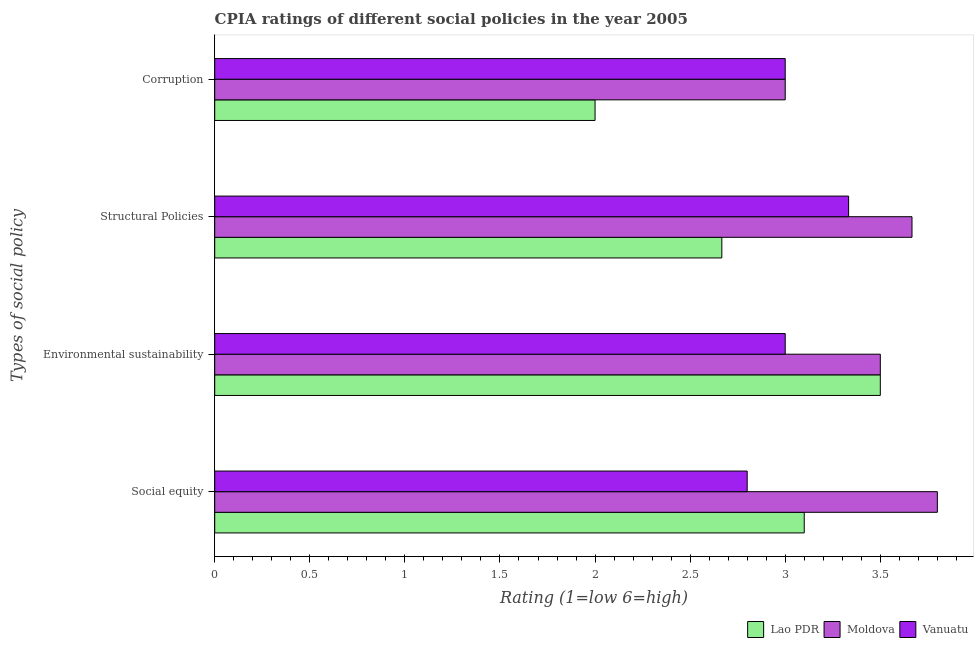How many different coloured bars are there?
Your response must be concise. 3. How many groups of bars are there?
Keep it short and to the point. 4. Are the number of bars per tick equal to the number of legend labels?
Ensure brevity in your answer.  Yes. What is the label of the 3rd group of bars from the top?
Your response must be concise. Environmental sustainability. What is the cpia rating of corruption in Vanuatu?
Offer a terse response. 3. Across all countries, what is the minimum cpia rating of structural policies?
Make the answer very short. 2.67. In which country was the cpia rating of environmental sustainability maximum?
Ensure brevity in your answer.  Lao PDR. In which country was the cpia rating of environmental sustainability minimum?
Ensure brevity in your answer.  Vanuatu. What is the total cpia rating of structural policies in the graph?
Your answer should be compact. 9.67. What is the difference between the cpia rating of structural policies in Vanuatu and that in Lao PDR?
Your answer should be compact. 0.67. What is the difference between the cpia rating of social equity in Vanuatu and the cpia rating of environmental sustainability in Moldova?
Offer a very short reply. -0.7. What is the average cpia rating of corruption per country?
Make the answer very short. 2.67. What is the difference between the cpia rating of environmental sustainability and cpia rating of corruption in Vanuatu?
Ensure brevity in your answer.  0. In how many countries, is the cpia rating of social equity greater than 1.3 ?
Keep it short and to the point. 3. What is the ratio of the cpia rating of structural policies in Moldova to that in Lao PDR?
Offer a terse response. 1.37. Is the difference between the cpia rating of corruption in Moldova and Lao PDR greater than the difference between the cpia rating of social equity in Moldova and Lao PDR?
Your answer should be very brief. Yes. What is the difference between the highest and the second highest cpia rating of social equity?
Ensure brevity in your answer.  0.7. What is the difference between the highest and the lowest cpia rating of social equity?
Your answer should be compact. 1. Is the sum of the cpia rating of social equity in Vanuatu and Lao PDR greater than the maximum cpia rating of environmental sustainability across all countries?
Provide a succinct answer. Yes. What does the 2nd bar from the top in Social equity represents?
Make the answer very short. Moldova. What does the 3rd bar from the bottom in Corruption represents?
Offer a terse response. Vanuatu. Is it the case that in every country, the sum of the cpia rating of social equity and cpia rating of environmental sustainability is greater than the cpia rating of structural policies?
Your answer should be very brief. Yes. How many bars are there?
Offer a very short reply. 12. How many countries are there in the graph?
Offer a terse response. 3. What is the difference between two consecutive major ticks on the X-axis?
Offer a terse response. 0.5. Does the graph contain grids?
Offer a terse response. No. How many legend labels are there?
Keep it short and to the point. 3. How are the legend labels stacked?
Offer a terse response. Horizontal. What is the title of the graph?
Make the answer very short. CPIA ratings of different social policies in the year 2005. What is the label or title of the X-axis?
Your response must be concise. Rating (1=low 6=high). What is the label or title of the Y-axis?
Give a very brief answer. Types of social policy. What is the Rating (1=low 6=high) in Moldova in Environmental sustainability?
Keep it short and to the point. 3.5. What is the Rating (1=low 6=high) of Lao PDR in Structural Policies?
Keep it short and to the point. 2.67. What is the Rating (1=low 6=high) of Moldova in Structural Policies?
Provide a short and direct response. 3.67. What is the Rating (1=low 6=high) of Vanuatu in Structural Policies?
Give a very brief answer. 3.33. What is the Rating (1=low 6=high) in Moldova in Corruption?
Offer a terse response. 3. What is the Rating (1=low 6=high) of Vanuatu in Corruption?
Make the answer very short. 3. Across all Types of social policy, what is the maximum Rating (1=low 6=high) of Moldova?
Keep it short and to the point. 3.8. Across all Types of social policy, what is the maximum Rating (1=low 6=high) of Vanuatu?
Your answer should be compact. 3.33. Across all Types of social policy, what is the minimum Rating (1=low 6=high) of Vanuatu?
Keep it short and to the point. 2.8. What is the total Rating (1=low 6=high) of Lao PDR in the graph?
Offer a terse response. 11.27. What is the total Rating (1=low 6=high) in Moldova in the graph?
Your response must be concise. 13.97. What is the total Rating (1=low 6=high) in Vanuatu in the graph?
Ensure brevity in your answer.  12.13. What is the difference between the Rating (1=low 6=high) of Vanuatu in Social equity and that in Environmental sustainability?
Your response must be concise. -0.2. What is the difference between the Rating (1=low 6=high) of Lao PDR in Social equity and that in Structural Policies?
Give a very brief answer. 0.43. What is the difference between the Rating (1=low 6=high) in Moldova in Social equity and that in Structural Policies?
Provide a short and direct response. 0.13. What is the difference between the Rating (1=low 6=high) in Vanuatu in Social equity and that in Structural Policies?
Your response must be concise. -0.53. What is the difference between the Rating (1=low 6=high) in Moldova in Social equity and that in Corruption?
Offer a very short reply. 0.8. What is the difference between the Rating (1=low 6=high) in Vanuatu in Social equity and that in Corruption?
Offer a terse response. -0.2. What is the difference between the Rating (1=low 6=high) in Lao PDR in Environmental sustainability and that in Structural Policies?
Keep it short and to the point. 0.83. What is the difference between the Rating (1=low 6=high) of Moldova in Environmental sustainability and that in Structural Policies?
Offer a very short reply. -0.17. What is the difference between the Rating (1=low 6=high) of Vanuatu in Environmental sustainability and that in Structural Policies?
Your answer should be very brief. -0.33. What is the difference between the Rating (1=low 6=high) in Moldova in Environmental sustainability and that in Corruption?
Your response must be concise. 0.5. What is the difference between the Rating (1=low 6=high) in Vanuatu in Environmental sustainability and that in Corruption?
Give a very brief answer. 0. What is the difference between the Rating (1=low 6=high) in Lao PDR in Structural Policies and that in Corruption?
Provide a short and direct response. 0.67. What is the difference between the Rating (1=low 6=high) of Moldova in Social equity and the Rating (1=low 6=high) of Vanuatu in Environmental sustainability?
Keep it short and to the point. 0.8. What is the difference between the Rating (1=low 6=high) of Lao PDR in Social equity and the Rating (1=low 6=high) of Moldova in Structural Policies?
Make the answer very short. -0.57. What is the difference between the Rating (1=low 6=high) in Lao PDR in Social equity and the Rating (1=low 6=high) in Vanuatu in Structural Policies?
Offer a terse response. -0.23. What is the difference between the Rating (1=low 6=high) in Moldova in Social equity and the Rating (1=low 6=high) in Vanuatu in Structural Policies?
Offer a terse response. 0.47. What is the difference between the Rating (1=low 6=high) in Lao PDR in Environmental sustainability and the Rating (1=low 6=high) in Vanuatu in Structural Policies?
Provide a succinct answer. 0.17. What is the difference between the Rating (1=low 6=high) of Moldova in Environmental sustainability and the Rating (1=low 6=high) of Vanuatu in Structural Policies?
Offer a very short reply. 0.17. What is the difference between the Rating (1=low 6=high) in Lao PDR in Environmental sustainability and the Rating (1=low 6=high) in Moldova in Corruption?
Make the answer very short. 0.5. What is the difference between the Rating (1=low 6=high) in Lao PDR in Structural Policies and the Rating (1=low 6=high) in Vanuatu in Corruption?
Ensure brevity in your answer.  -0.33. What is the difference between the Rating (1=low 6=high) of Moldova in Structural Policies and the Rating (1=low 6=high) of Vanuatu in Corruption?
Your answer should be very brief. 0.67. What is the average Rating (1=low 6=high) in Lao PDR per Types of social policy?
Make the answer very short. 2.82. What is the average Rating (1=low 6=high) in Moldova per Types of social policy?
Ensure brevity in your answer.  3.49. What is the average Rating (1=low 6=high) of Vanuatu per Types of social policy?
Give a very brief answer. 3.03. What is the difference between the Rating (1=low 6=high) in Lao PDR and Rating (1=low 6=high) in Moldova in Social equity?
Provide a succinct answer. -0.7. What is the difference between the Rating (1=low 6=high) of Lao PDR and Rating (1=low 6=high) of Vanuatu in Social equity?
Offer a very short reply. 0.3. What is the difference between the Rating (1=low 6=high) in Lao PDR and Rating (1=low 6=high) in Moldova in Environmental sustainability?
Provide a short and direct response. 0. What is the difference between the Rating (1=low 6=high) of Lao PDR and Rating (1=low 6=high) of Vanuatu in Environmental sustainability?
Your response must be concise. 0.5. What is the difference between the Rating (1=low 6=high) of Lao PDR and Rating (1=low 6=high) of Moldova in Structural Policies?
Your answer should be compact. -1. What is the difference between the Rating (1=low 6=high) in Lao PDR and Rating (1=low 6=high) in Vanuatu in Structural Policies?
Keep it short and to the point. -0.67. What is the difference between the Rating (1=low 6=high) of Moldova and Rating (1=low 6=high) of Vanuatu in Structural Policies?
Provide a succinct answer. 0.33. What is the difference between the Rating (1=low 6=high) in Lao PDR and Rating (1=low 6=high) in Moldova in Corruption?
Offer a terse response. -1. What is the difference between the Rating (1=low 6=high) of Lao PDR and Rating (1=low 6=high) of Vanuatu in Corruption?
Your answer should be very brief. -1. What is the ratio of the Rating (1=low 6=high) of Lao PDR in Social equity to that in Environmental sustainability?
Provide a succinct answer. 0.89. What is the ratio of the Rating (1=low 6=high) in Moldova in Social equity to that in Environmental sustainability?
Your answer should be very brief. 1.09. What is the ratio of the Rating (1=low 6=high) in Lao PDR in Social equity to that in Structural Policies?
Offer a terse response. 1.16. What is the ratio of the Rating (1=low 6=high) in Moldova in Social equity to that in Structural Policies?
Provide a succinct answer. 1.04. What is the ratio of the Rating (1=low 6=high) of Vanuatu in Social equity to that in Structural Policies?
Provide a succinct answer. 0.84. What is the ratio of the Rating (1=low 6=high) in Lao PDR in Social equity to that in Corruption?
Provide a succinct answer. 1.55. What is the ratio of the Rating (1=low 6=high) in Moldova in Social equity to that in Corruption?
Your answer should be very brief. 1.27. What is the ratio of the Rating (1=low 6=high) in Vanuatu in Social equity to that in Corruption?
Provide a succinct answer. 0.93. What is the ratio of the Rating (1=low 6=high) in Lao PDR in Environmental sustainability to that in Structural Policies?
Provide a succinct answer. 1.31. What is the ratio of the Rating (1=low 6=high) of Moldova in Environmental sustainability to that in Structural Policies?
Your answer should be compact. 0.95. What is the ratio of the Rating (1=low 6=high) in Moldova in Environmental sustainability to that in Corruption?
Offer a very short reply. 1.17. What is the ratio of the Rating (1=low 6=high) of Vanuatu in Environmental sustainability to that in Corruption?
Give a very brief answer. 1. What is the ratio of the Rating (1=low 6=high) in Moldova in Structural Policies to that in Corruption?
Give a very brief answer. 1.22. What is the difference between the highest and the second highest Rating (1=low 6=high) of Moldova?
Your response must be concise. 0.13. What is the difference between the highest and the second highest Rating (1=low 6=high) of Vanuatu?
Offer a terse response. 0.33. What is the difference between the highest and the lowest Rating (1=low 6=high) of Lao PDR?
Your answer should be very brief. 1.5. What is the difference between the highest and the lowest Rating (1=low 6=high) of Vanuatu?
Offer a terse response. 0.53. 